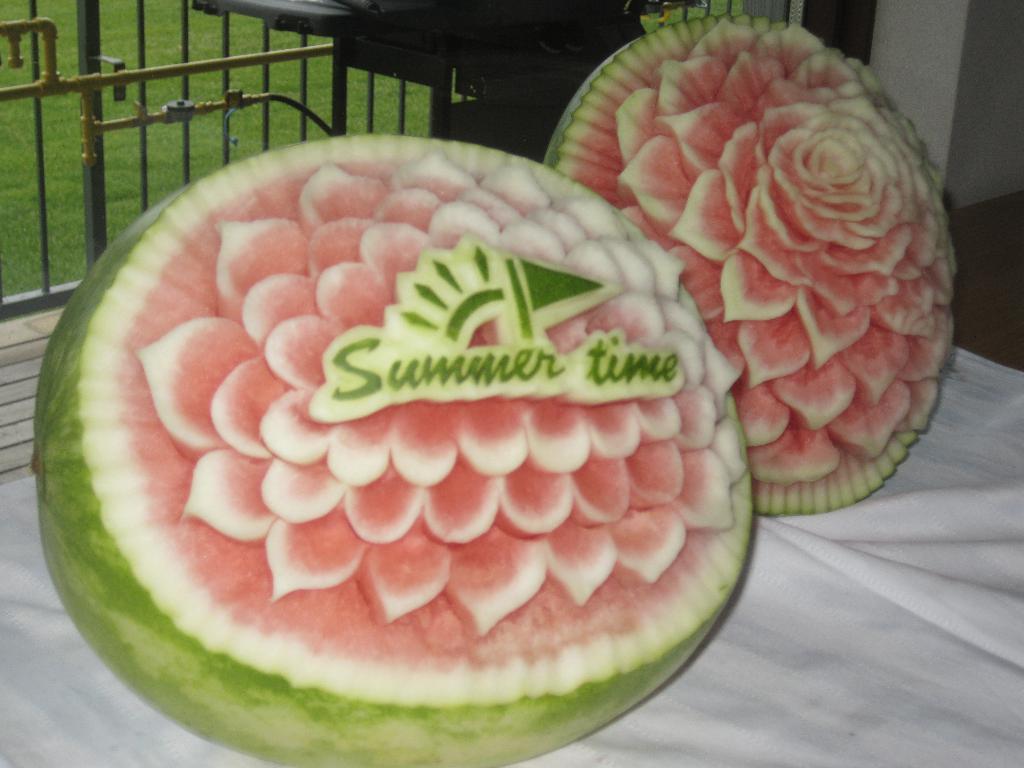Please provide a concise description of this image. In this picture I can see two carved watermelons on an object, and in the background there are some items, pipes, iron grills and grass. 